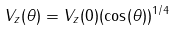<formula> <loc_0><loc_0><loc_500><loc_500>V _ { z } ( \theta ) = V _ { z } ( 0 ) ( \cos ( \theta ) ) ^ { 1 / 4 }</formula> 